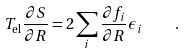Convert formula to latex. <formula><loc_0><loc_0><loc_500><loc_500>T _ { \text {el} } \frac { \partial S } { \partial { R } } = 2 \sum _ { i } \frac { \partial f _ { i } } { \partial { R } } \epsilon _ { i } \quad .</formula> 